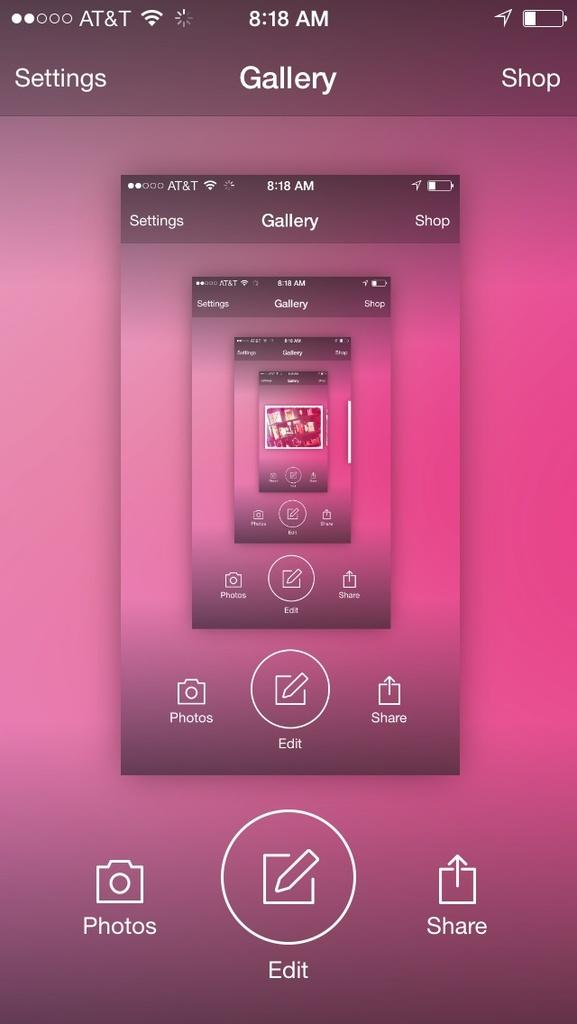<image>
Render a clear and concise summary of the photo. An image on a smartphone on AT&T service in the Gallery app. 